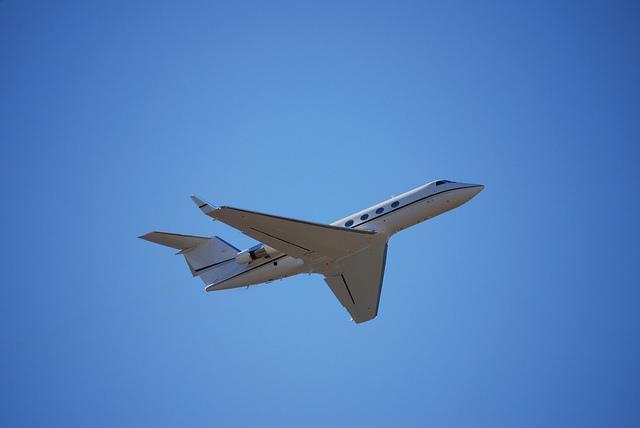How many tires can you see in this photo?
Give a very brief answer. 0. How many airplanes are there?
Give a very brief answer. 1. 